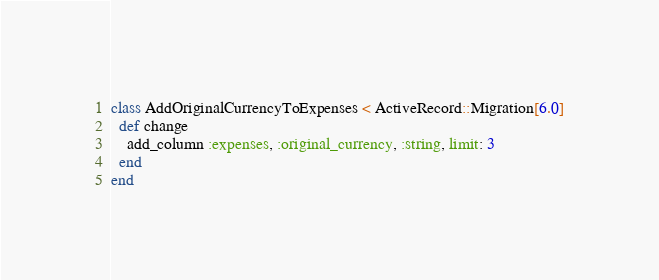Convert code to text. <code><loc_0><loc_0><loc_500><loc_500><_Ruby_>class AddOriginalCurrencyToExpenses < ActiveRecord::Migration[6.0]
  def change
    add_column :expenses, :original_currency, :string, limit: 3
  end
end
</code> 